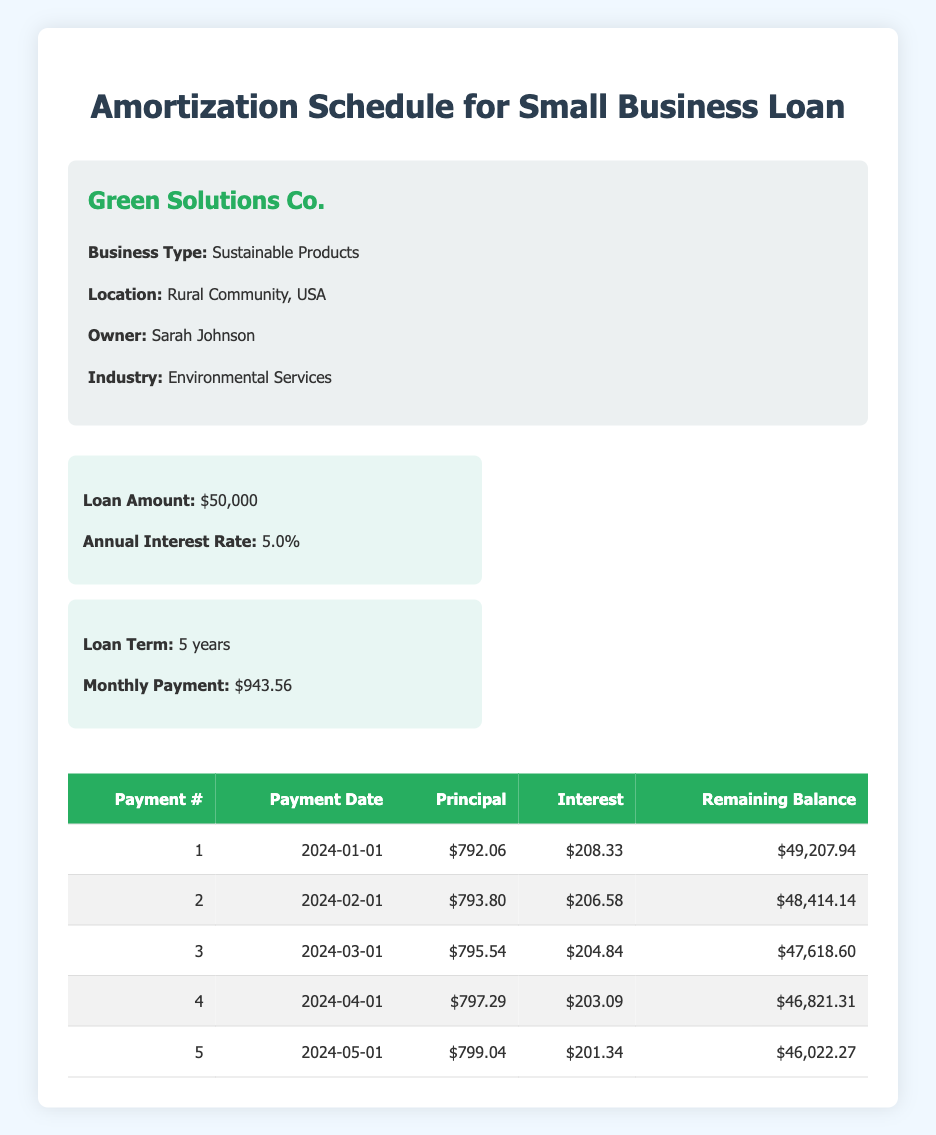What is the total loan amount for Green Solutions Co.? The loan amount is stated as $50,000 in the loan details section of the table.
Answer: 50,000 What is the monthly payment amount for the loan? The table specifies that the monthly payment for the loan is $943.56.
Answer: 943.56 What was the principal payment for the third payment? In the amortization schedule, the third payment shows a principal payment of $795.54.
Answer: 795.54 True or False: The interest payment for the first payment is higher than the second payment. The interest payment for the first payment is $208.33 and for the second payment is $206.58. Since $208.33 is greater than $206.58, the statement is true.
Answer: True What is the total principal paid in the first five payments? To find the total principal paid, sum the principal payments: 792.06 + 793.80 + 795.54 + 797.29 + 799.04 = 3977.73.
Answer: 3977.73 What is the average interest payment over the first five months? To find the average interest payment, sum the interest payments (208.33 + 206.58 + 204.84 + 203.09 + 201.34 = 1024.18) and divide by the number of payments (5). Therefore, the average is 1024.18 / 5 = 204.84.
Answer: 204.84 Which month has the highest interest payment? By reviewing the interest payments for the first five months ($208.33, $206.58, $204.84, $203.09, and $201.34), the highest interest payment is for the first payment in January at $208.33.
Answer: January What is the remaining balance after the fifth payment? According to the amortization schedule, the remaining balance after the fifth payment is listed as $46,022.27.
Answer: 46,022.27 True or False: The principal payment increases with each successive payment. By examining the principal payments (792.06, 793.80, 795.54, 797.29, 799.04), it is evident that each value is greater than the previous one, confirming the statement is true.
Answer: True 